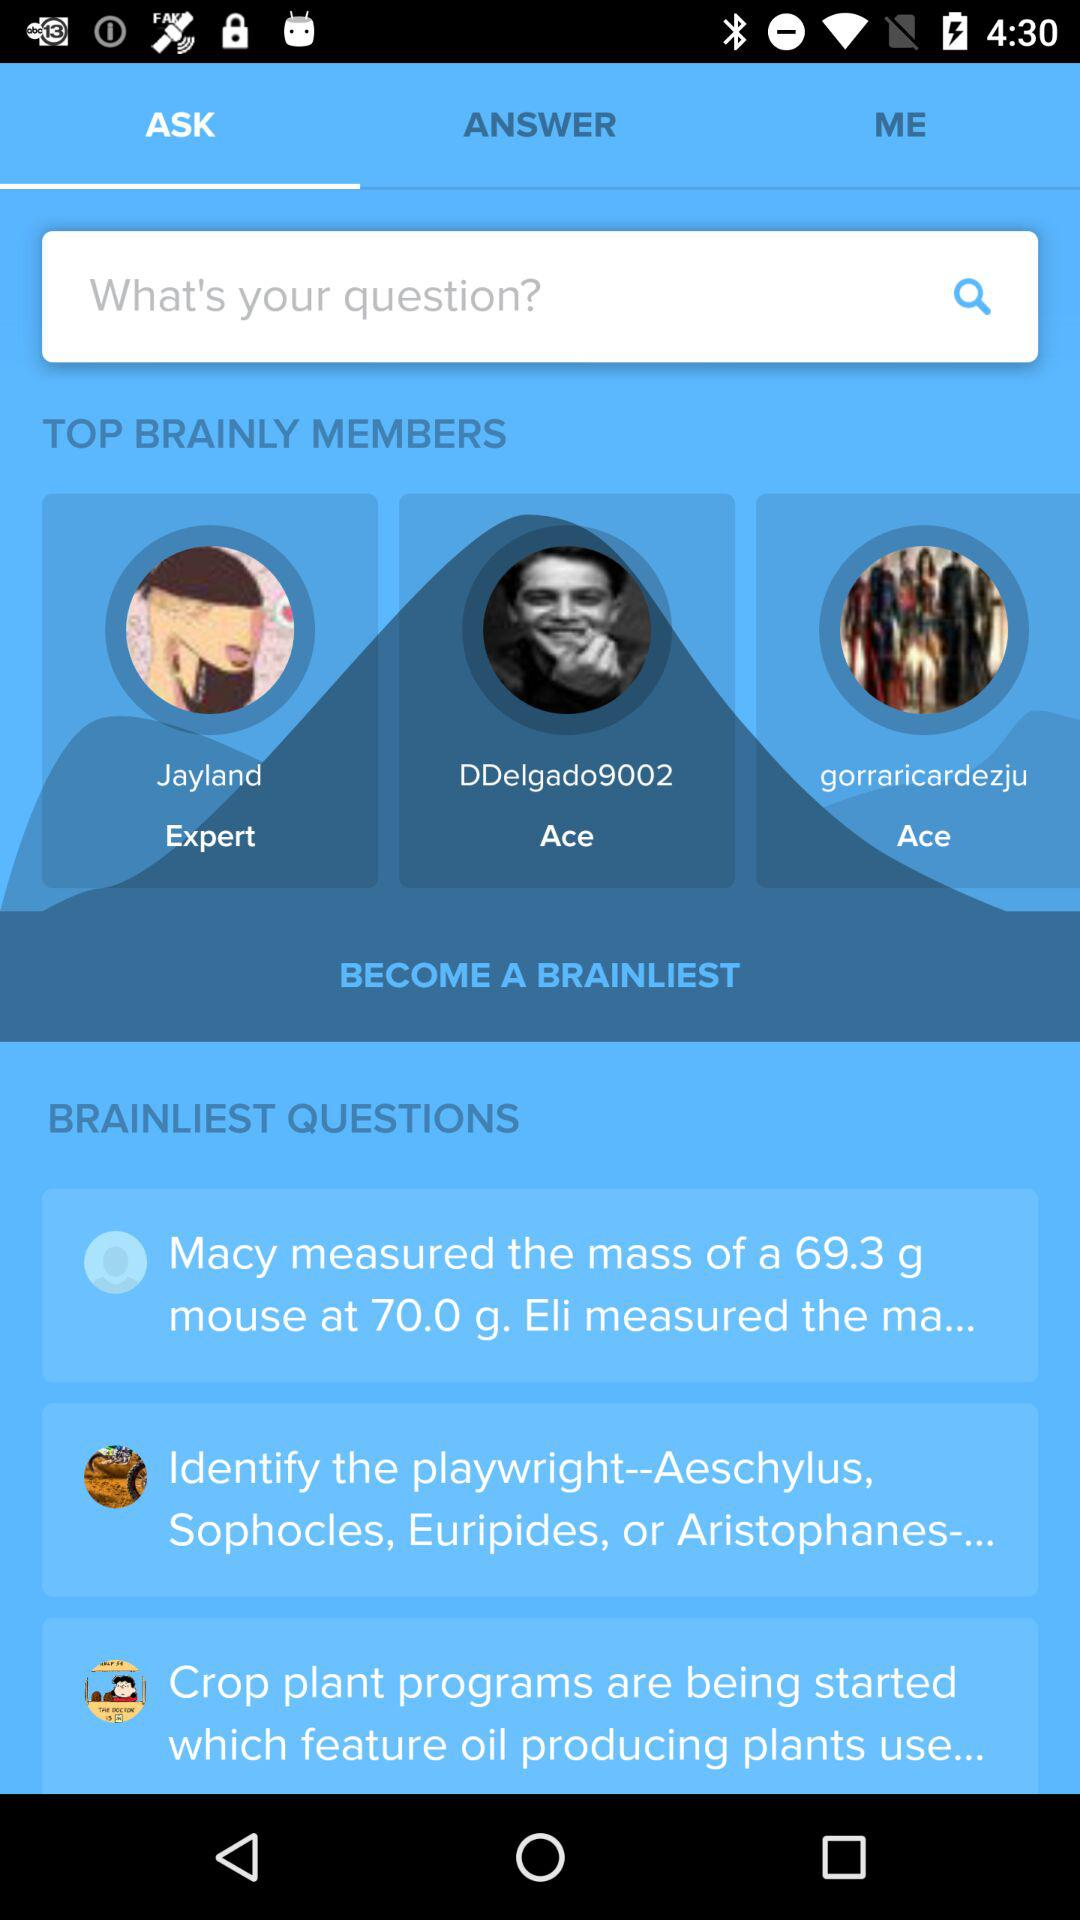Which tab is selected? The selected tab is "ASK". 